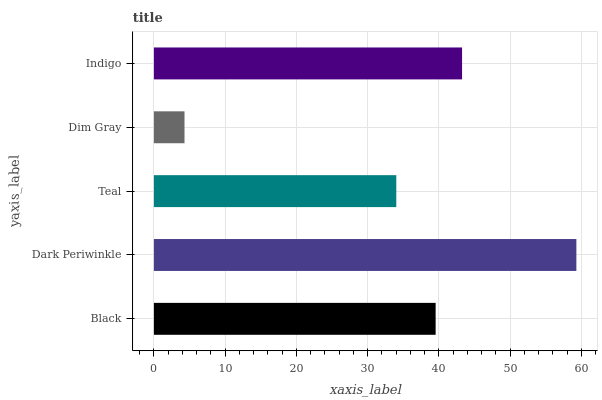Is Dim Gray the minimum?
Answer yes or no. Yes. Is Dark Periwinkle the maximum?
Answer yes or no. Yes. Is Teal the minimum?
Answer yes or no. No. Is Teal the maximum?
Answer yes or no. No. Is Dark Periwinkle greater than Teal?
Answer yes or no. Yes. Is Teal less than Dark Periwinkle?
Answer yes or no. Yes. Is Teal greater than Dark Periwinkle?
Answer yes or no. No. Is Dark Periwinkle less than Teal?
Answer yes or no. No. Is Black the high median?
Answer yes or no. Yes. Is Black the low median?
Answer yes or no. Yes. Is Teal the high median?
Answer yes or no. No. Is Indigo the low median?
Answer yes or no. No. 